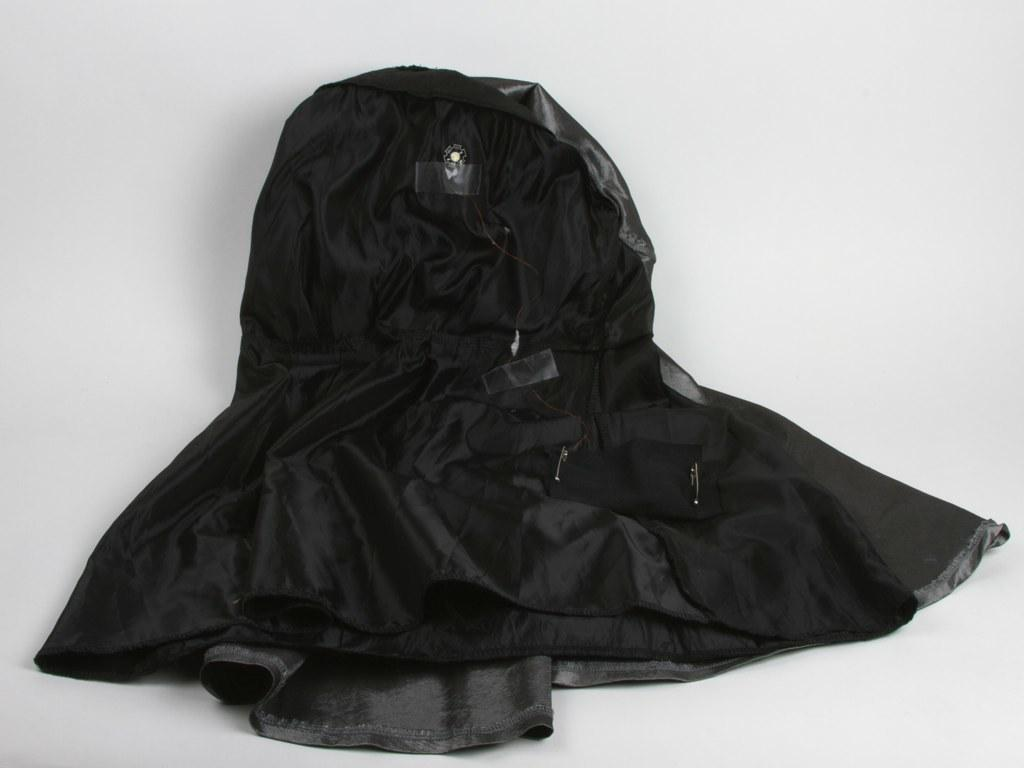What is the main object in the image? There is a black cloth in the image. What does the black cloth resemble? The black cloth resembles a hat. Where is the basin located in the image? There is no basin present in the image. What type of pencil can be seen being used to draw on the road in the image? There is no pencil or road present in the image. 